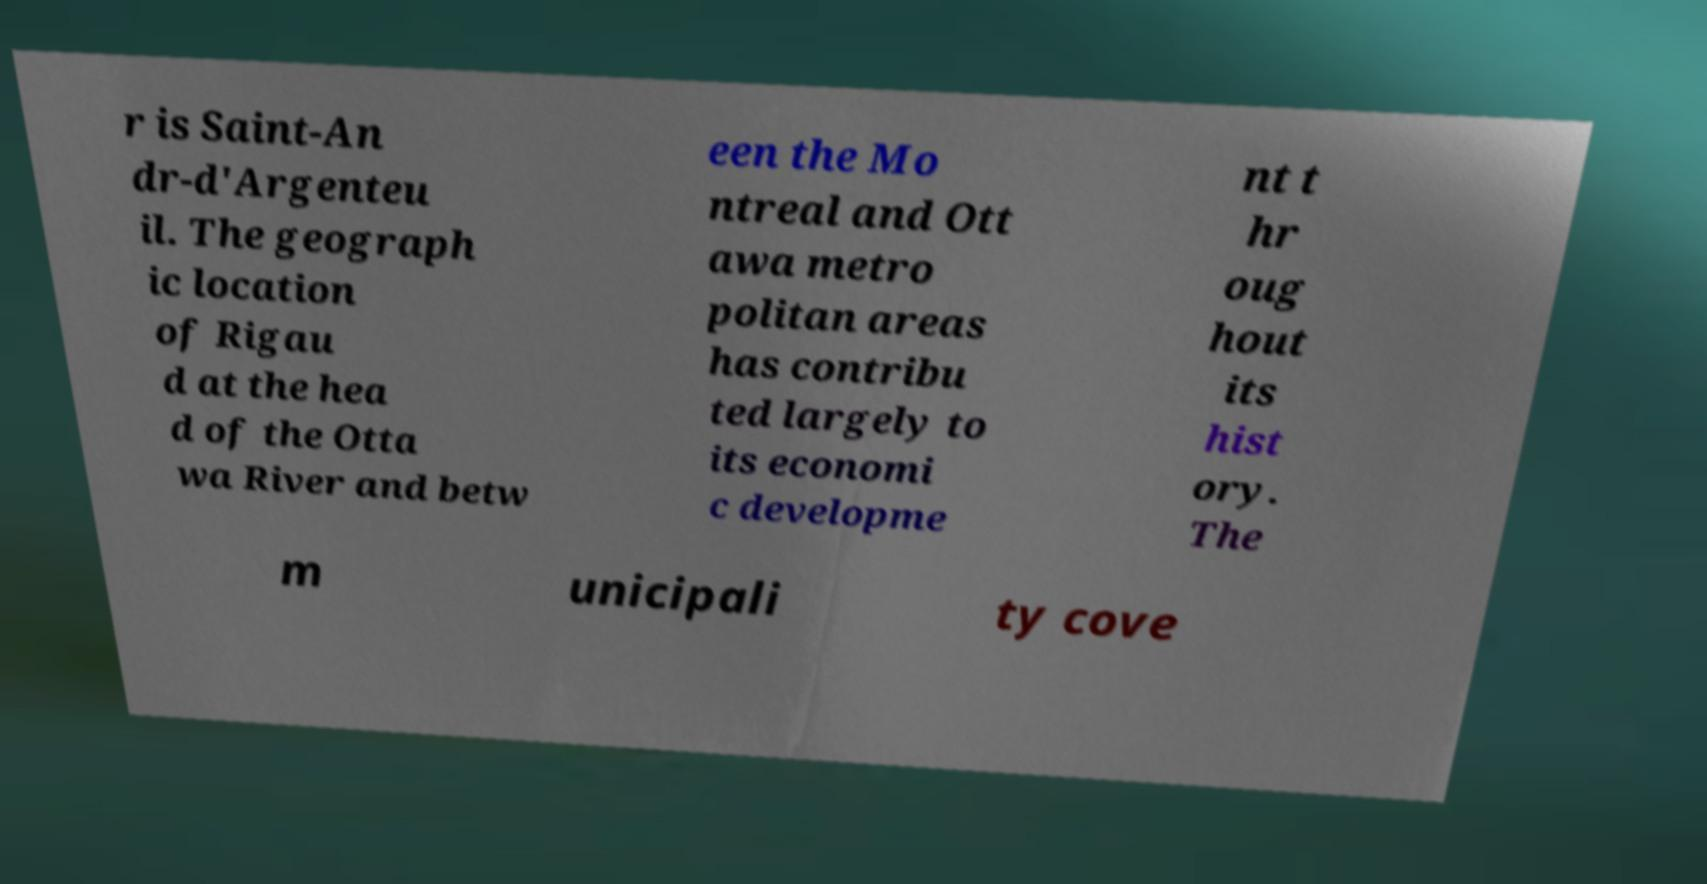There's text embedded in this image that I need extracted. Can you transcribe it verbatim? r is Saint-An dr-d'Argenteu il. The geograph ic location of Rigau d at the hea d of the Otta wa River and betw een the Mo ntreal and Ott awa metro politan areas has contribu ted largely to its economi c developme nt t hr oug hout its hist ory. The m unicipali ty cove 